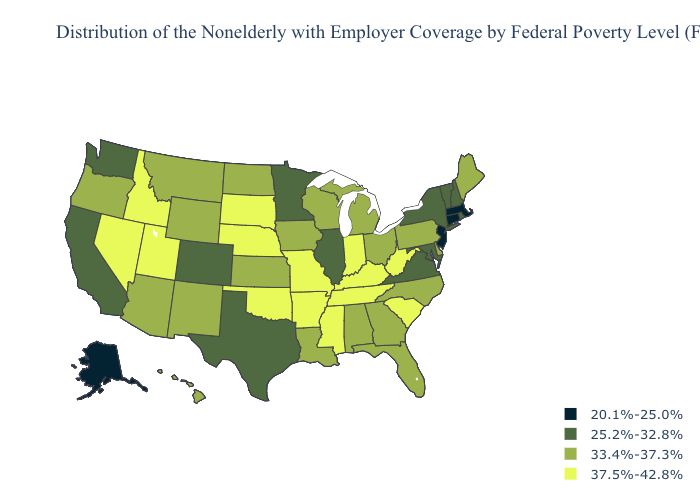What is the value of Idaho?
Be succinct. 37.5%-42.8%. Among the states that border West Virginia , which have the highest value?
Write a very short answer. Kentucky. Name the states that have a value in the range 37.5%-42.8%?
Give a very brief answer. Arkansas, Idaho, Indiana, Kentucky, Mississippi, Missouri, Nebraska, Nevada, Oklahoma, South Carolina, South Dakota, Tennessee, Utah, West Virginia. What is the lowest value in the USA?
Be succinct. 20.1%-25.0%. What is the lowest value in states that border New York?
Short answer required. 20.1%-25.0%. Name the states that have a value in the range 37.5%-42.8%?
Short answer required. Arkansas, Idaho, Indiana, Kentucky, Mississippi, Missouri, Nebraska, Nevada, Oklahoma, South Carolina, South Dakota, Tennessee, Utah, West Virginia. What is the value of Tennessee?
Short answer required. 37.5%-42.8%. What is the highest value in states that border Georgia?
Quick response, please. 37.5%-42.8%. Which states hav the highest value in the West?
Give a very brief answer. Idaho, Nevada, Utah. What is the highest value in states that border North Dakota?
Quick response, please. 37.5%-42.8%. Among the states that border Missouri , which have the highest value?
Concise answer only. Arkansas, Kentucky, Nebraska, Oklahoma, Tennessee. Name the states that have a value in the range 25.2%-32.8%?
Give a very brief answer. California, Colorado, Illinois, Maryland, Minnesota, New Hampshire, New York, Rhode Island, Texas, Vermont, Virginia, Washington. Among the states that border Michigan , which have the lowest value?
Give a very brief answer. Ohio, Wisconsin. Name the states that have a value in the range 33.4%-37.3%?
Be succinct. Alabama, Arizona, Delaware, Florida, Georgia, Hawaii, Iowa, Kansas, Louisiana, Maine, Michigan, Montana, New Mexico, North Carolina, North Dakota, Ohio, Oregon, Pennsylvania, Wisconsin, Wyoming. What is the highest value in states that border Maryland?
Concise answer only. 37.5%-42.8%. 